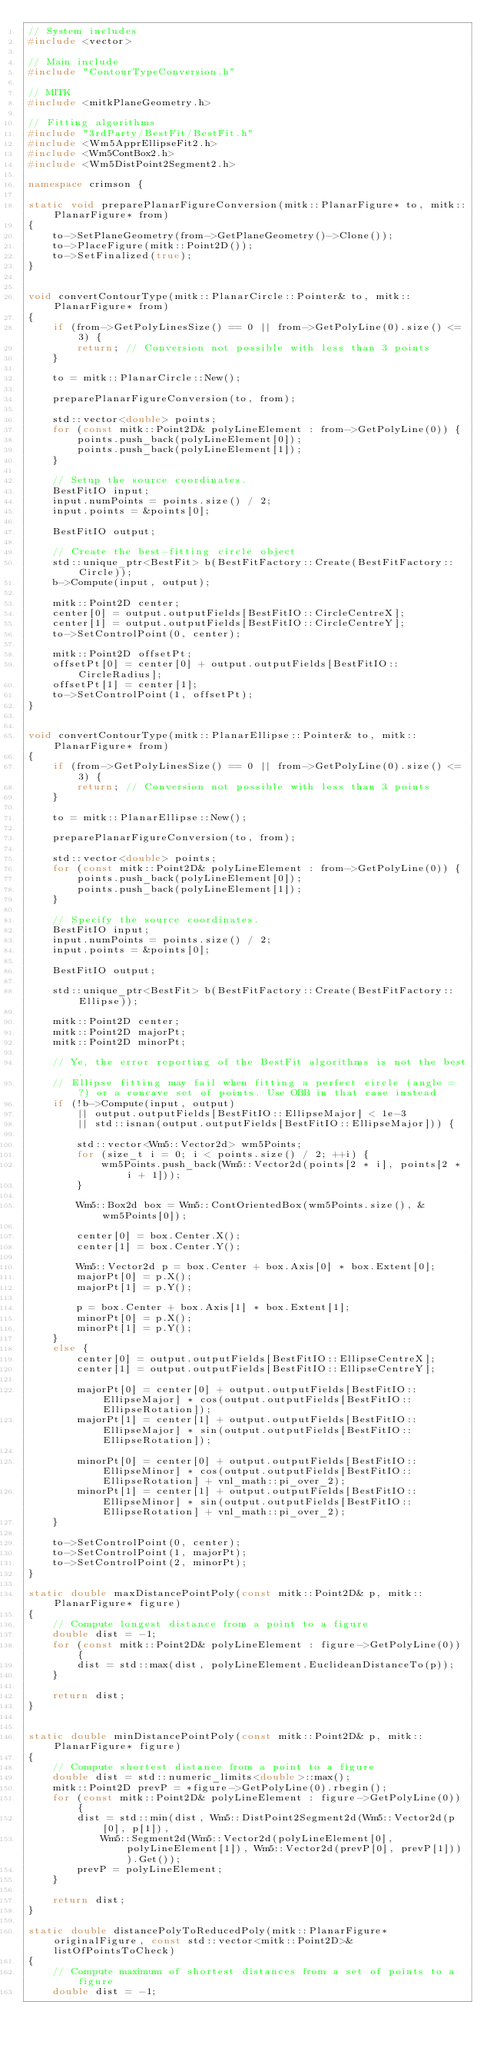Convert code to text. <code><loc_0><loc_0><loc_500><loc_500><_C++_>// System includes
#include <vector>

// Main include
#include "ContourTypeConversion.h"

// MITK
#include <mitkPlaneGeometry.h>

// Fitting algorithms
#include "3rdParty/BestFit/BestFit.h"
#include <Wm5ApprEllipseFit2.h>
#include <Wm5ContBox2.h>
#include <Wm5DistPoint2Segment2.h>

namespace crimson {

static void preparePlanarFigureConversion(mitk::PlanarFigure* to, mitk::PlanarFigure* from)
{
    to->SetPlaneGeometry(from->GetPlaneGeometry()->Clone());
    to->PlaceFigure(mitk::Point2D());
    to->SetFinalized(true);
}


void convertContourType(mitk::PlanarCircle::Pointer& to, mitk::PlanarFigure* from)
{
    if (from->GetPolyLinesSize() == 0 || from->GetPolyLine(0).size() <= 3) {
        return; // Conversion not possible with less than 3 points
    }

    to = mitk::PlanarCircle::New();

    preparePlanarFigureConversion(to, from);

    std::vector<double> points;
    for (const mitk::Point2D& polyLineElement : from->GetPolyLine(0)) {
        points.push_back(polyLineElement[0]);
        points.push_back(polyLineElement[1]);
    }

    // Setup the source coordinates.
    BestFitIO input;
    input.numPoints = points.size() / 2;
    input.points = &points[0];

    BestFitIO output;

    // Create the best-fitting circle object
    std::unique_ptr<BestFit> b(BestFitFactory::Create(BestFitFactory::Circle));
    b->Compute(input, output);

    mitk::Point2D center;
    center[0] = output.outputFields[BestFitIO::CircleCentreX];
    center[1] = output.outputFields[BestFitIO::CircleCentreY];
    to->SetControlPoint(0, center);

    mitk::Point2D offsetPt;
    offsetPt[0] = center[0] + output.outputFields[BestFitIO::CircleRadius];
    offsetPt[1] = center[1];
    to->SetControlPoint(1, offsetPt);
}


void convertContourType(mitk::PlanarEllipse::Pointer& to, mitk::PlanarFigure* from)
{
    if (from->GetPolyLinesSize() == 0 || from->GetPolyLine(0).size() <= 3) {
        return; // Conversion not possible with less than 3 points
    }

    to = mitk::PlanarEllipse::New();

    preparePlanarFigureConversion(to, from);

    std::vector<double> points;
    for (const mitk::Point2D& polyLineElement : from->GetPolyLine(0)) {
        points.push_back(polyLineElement[0]);
        points.push_back(polyLineElement[1]);
    }

    // Specify the source coordinates.
    BestFitIO input;
    input.numPoints = points.size() / 2;
    input.points = &points[0];

    BestFitIO output;

    std::unique_ptr<BestFit> b(BestFitFactory::Create(BestFitFactory::Ellipse));

    mitk::Point2D center;
    mitk::Point2D majorPt;
    mitk::Point2D minorPt;

    // Ye, the error reporting of the BestFit algorithms is not the best. 
    // Ellipse fitting may fail when fitting a perfect circle (angle = ?) or a concave set of points. Use OBB in that case instead
    if (!b->Compute(input, output)
        || output.outputFields[BestFitIO::EllipseMajor] < 1e-3
        || std::isnan(output.outputFields[BestFitIO::EllipseMajor])) {

        std::vector<Wm5::Vector2d> wm5Points;
        for (size_t i = 0; i < points.size() / 2; ++i) {
            wm5Points.push_back(Wm5::Vector2d(points[2 * i], points[2 * i + 1]));
        }

        Wm5::Box2d box = Wm5::ContOrientedBox(wm5Points.size(), &wm5Points[0]);

        center[0] = box.Center.X();
        center[1] = box.Center.Y();

        Wm5::Vector2d p = box.Center + box.Axis[0] * box.Extent[0];
        majorPt[0] = p.X();
        majorPt[1] = p.Y();

        p = box.Center + box.Axis[1] * box.Extent[1];
        minorPt[0] = p.X();
        minorPt[1] = p.Y();
    }
    else {
        center[0] = output.outputFields[BestFitIO::EllipseCentreX];
        center[1] = output.outputFields[BestFitIO::EllipseCentreY];

        majorPt[0] = center[0] + output.outputFields[BestFitIO::EllipseMajor] * cos(output.outputFields[BestFitIO::EllipseRotation]);
        majorPt[1] = center[1] + output.outputFields[BestFitIO::EllipseMajor] * sin(output.outputFields[BestFitIO::EllipseRotation]);

        minorPt[0] = center[0] + output.outputFields[BestFitIO::EllipseMinor] * cos(output.outputFields[BestFitIO::EllipseRotation] + vnl_math::pi_over_2);
        minorPt[1] = center[1] + output.outputFields[BestFitIO::EllipseMinor] * sin(output.outputFields[BestFitIO::EllipseRotation] + vnl_math::pi_over_2);
    }

    to->SetControlPoint(0, center);
    to->SetControlPoint(1, majorPt);
    to->SetControlPoint(2, minorPt);
}

static double maxDistancePointPoly(const mitk::Point2D& p, mitk::PlanarFigure* figure)
{
    // Compute longest distance from a point to a figure
    double dist = -1;
    for (const mitk::Point2D& polyLineElement : figure->GetPolyLine(0)) {
        dist = std::max(dist, polyLineElement.EuclideanDistanceTo(p));
    }

    return dist;
}


static double minDistancePointPoly(const mitk::Point2D& p, mitk::PlanarFigure* figure)
{
    // Compute shortest distance from a point to a figure
    double dist = std::numeric_limits<double>::max();
    mitk::Point2D prevP = *figure->GetPolyLine(0).rbegin();
    for (const mitk::Point2D& polyLineElement : figure->GetPolyLine(0)) {
        dist = std::min(dist, Wm5::DistPoint2Segment2d(Wm5::Vector2d(p[0], p[1]), 
            Wm5::Segment2d(Wm5::Vector2d(polyLineElement[0], polyLineElement[1]), Wm5::Vector2d(prevP[0], prevP[1]))).Get());
        prevP = polyLineElement;
    }

    return dist;
}                                                   

static double distancePolyToReducedPoly(mitk::PlanarFigure* originalFigure, const std::vector<mitk::Point2D>& listOfPointsToCheck)
{
    // Compute maximum of shortest distances from a set of points to a figure
    double dist = -1;
</code> 